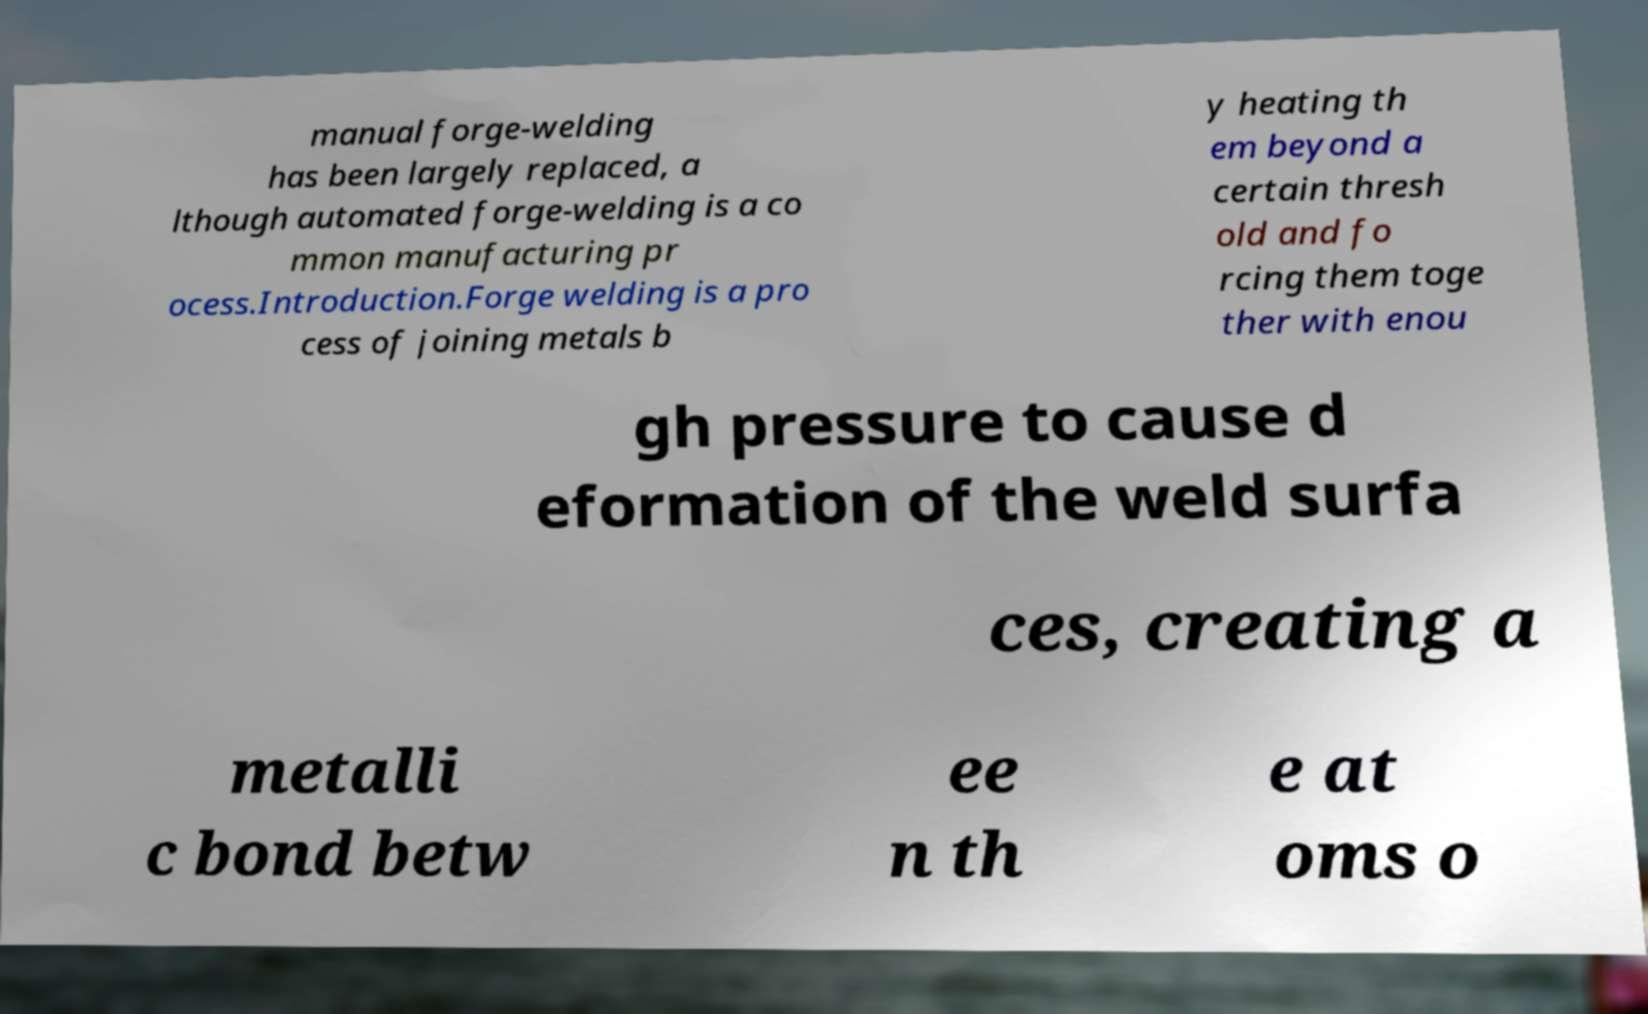Can you read and provide the text displayed in the image?This photo seems to have some interesting text. Can you extract and type it out for me? manual forge-welding has been largely replaced, a lthough automated forge-welding is a co mmon manufacturing pr ocess.Introduction.Forge welding is a pro cess of joining metals b y heating th em beyond a certain thresh old and fo rcing them toge ther with enou gh pressure to cause d eformation of the weld surfa ces, creating a metalli c bond betw ee n th e at oms o 